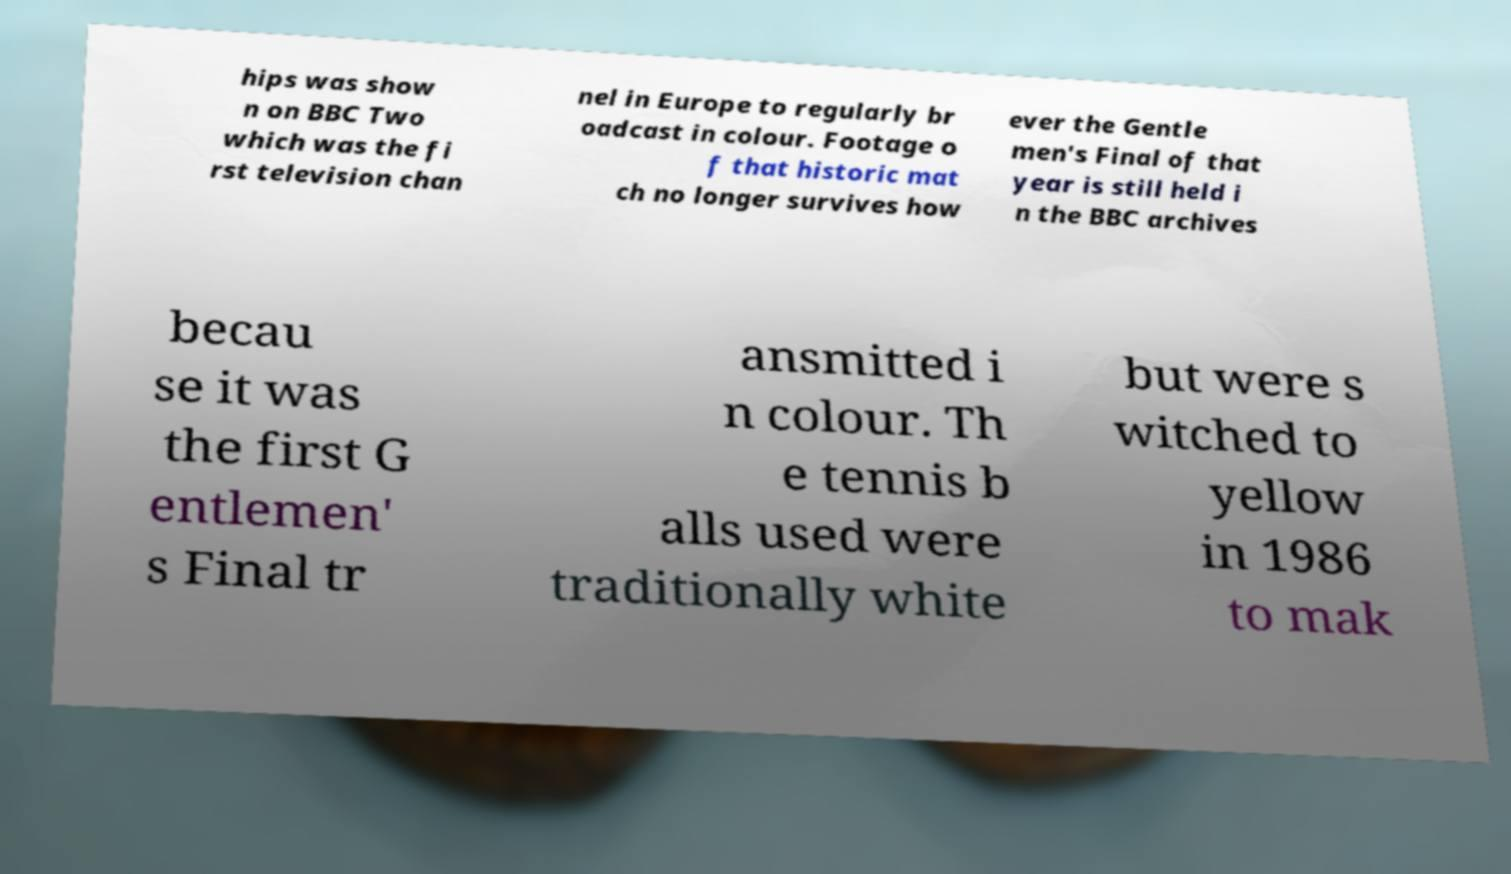I need the written content from this picture converted into text. Can you do that? hips was show n on BBC Two which was the fi rst television chan nel in Europe to regularly br oadcast in colour. Footage o f that historic mat ch no longer survives how ever the Gentle men's Final of that year is still held i n the BBC archives becau se it was the first G entlemen' s Final tr ansmitted i n colour. Th e tennis b alls used were traditionally white but were s witched to yellow in 1986 to mak 